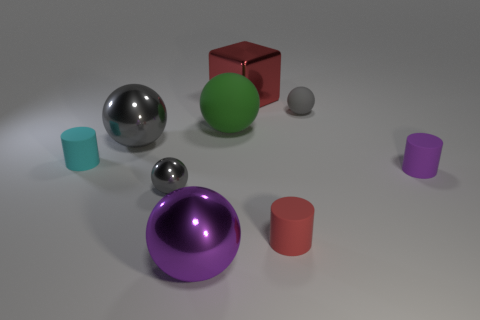Subtract all purple cylinders. How many gray balls are left? 3 Subtract all green balls. How many balls are left? 4 Subtract all tiny matte balls. How many balls are left? 4 Subtract all cyan spheres. Subtract all yellow cubes. How many spheres are left? 5 Subtract all balls. How many objects are left? 4 Subtract 1 cyan cylinders. How many objects are left? 8 Subtract all large blue shiny blocks. Subtract all matte cylinders. How many objects are left? 6 Add 5 tiny metallic things. How many tiny metallic things are left? 6 Add 2 big green objects. How many big green objects exist? 3 